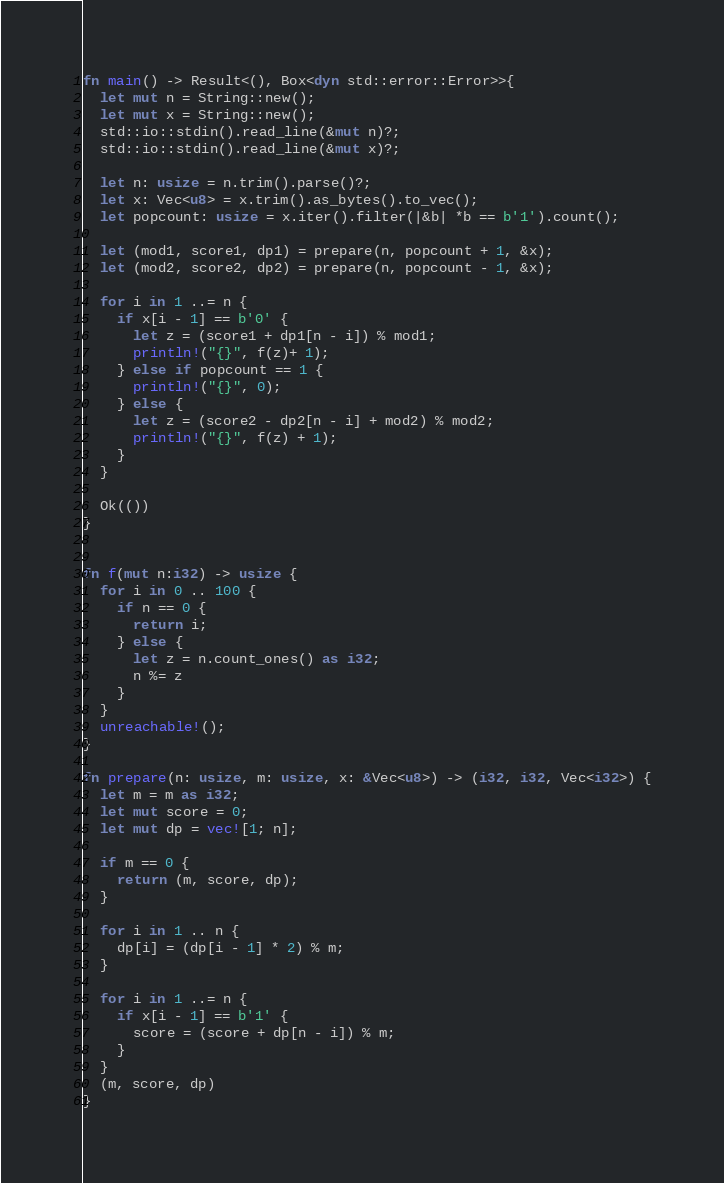Convert code to text. <code><loc_0><loc_0><loc_500><loc_500><_Rust_>

fn main() -> Result<(), Box<dyn std::error::Error>>{
  let mut n = String::new();
  let mut x = String::new();
  std::io::stdin().read_line(&mut n)?;
  std::io::stdin().read_line(&mut x)?;
  
  let n: usize = n.trim().parse()?;
  let x: Vec<u8> = x.trim().as_bytes().to_vec();
  let popcount: usize = x.iter().filter(|&b| *b == b'1').count();

  let (mod1, score1, dp1) = prepare(n, popcount + 1, &x);
  let (mod2, score2, dp2) = prepare(n, popcount - 1, &x);
  
  for i in 1 ..= n {
    if x[i - 1] == b'0' {
      let z = (score1 + dp1[n - i]) % mod1;
      println!("{}", f(z)+ 1);
    } else if popcount == 1 {
      println!("{}", 0);
    } else {
      let z = (score2 - dp2[n - i] + mod2) % mod2;
      println!("{}", f(z) + 1);
    }
  }
  
  Ok(())
}


fn f(mut n:i32) -> usize {
  for i in 0 .. 100 {
    if n == 0 {
      return i;
    } else {
      let z = n.count_ones() as i32;
      n %= z
    }
  }
  unreachable!();
}

fn prepare(n: usize, m: usize, x: &Vec<u8>) -> (i32, i32, Vec<i32>) {
  let m = m as i32;
  let mut score = 0;
  let mut dp = vec![1; n];

  if m == 0 {
    return (m, score, dp);
  }
  
  for i in 1 .. n {
    dp[i] = (dp[i - 1] * 2) % m;
  }
  
  for i in 1 ..= n {
    if x[i - 1] == b'1' {
      score = (score + dp[n - i]) % m;
    }
  }
  (m, score, dp)
}
</code> 